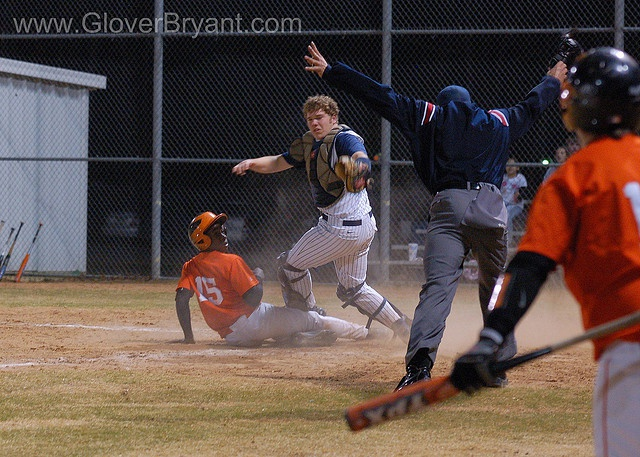Describe the objects in this image and their specific colors. I can see people in black, maroon, brown, and gray tones, people in black, gray, and navy tones, people in black, gray, and darkgray tones, people in black, gray, maroon, and brown tones, and baseball bat in black, maroon, and gray tones in this image. 